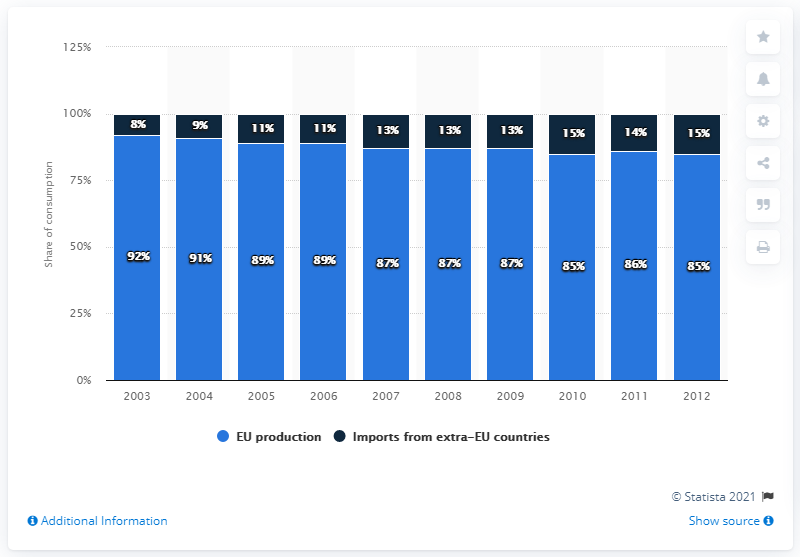Draw attention to some important aspects in this diagram. The consumption of furniture in the European Union came to an end in 2012. 